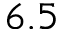<formula> <loc_0><loc_0><loc_500><loc_500>6 . 5</formula> 